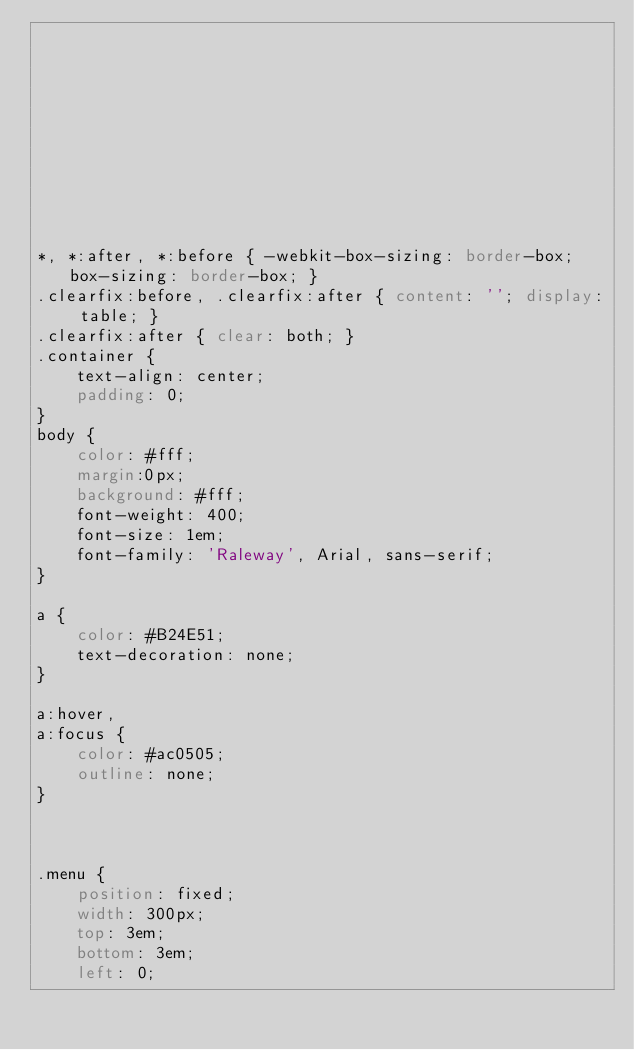<code> <loc_0><loc_0><loc_500><loc_500><_CSS_>










*, *:after, *:before { -webkit-box-sizing: border-box; box-sizing: border-box; }
.clearfix:before, .clearfix:after { content: ''; display: table; }
.clearfix:after { clear: both; }
.container {
	text-align: center;
	padding: 0;
}
body {
	color: #fff;
    margin:0px;
	background: #fff;
	font-weight: 400;
	font-size: 1em;
	font-family: 'Raleway', Arial, sans-serif;
}

a {
	color: #B24E51;
	text-decoration: none;
}

a:hover,
a:focus {
	color: #ac0505;
	outline: none;
}



.menu {
	position: fixed;
	width: 300px;
	top: 3em;
	bottom: 3em;
	left: 0;</code> 